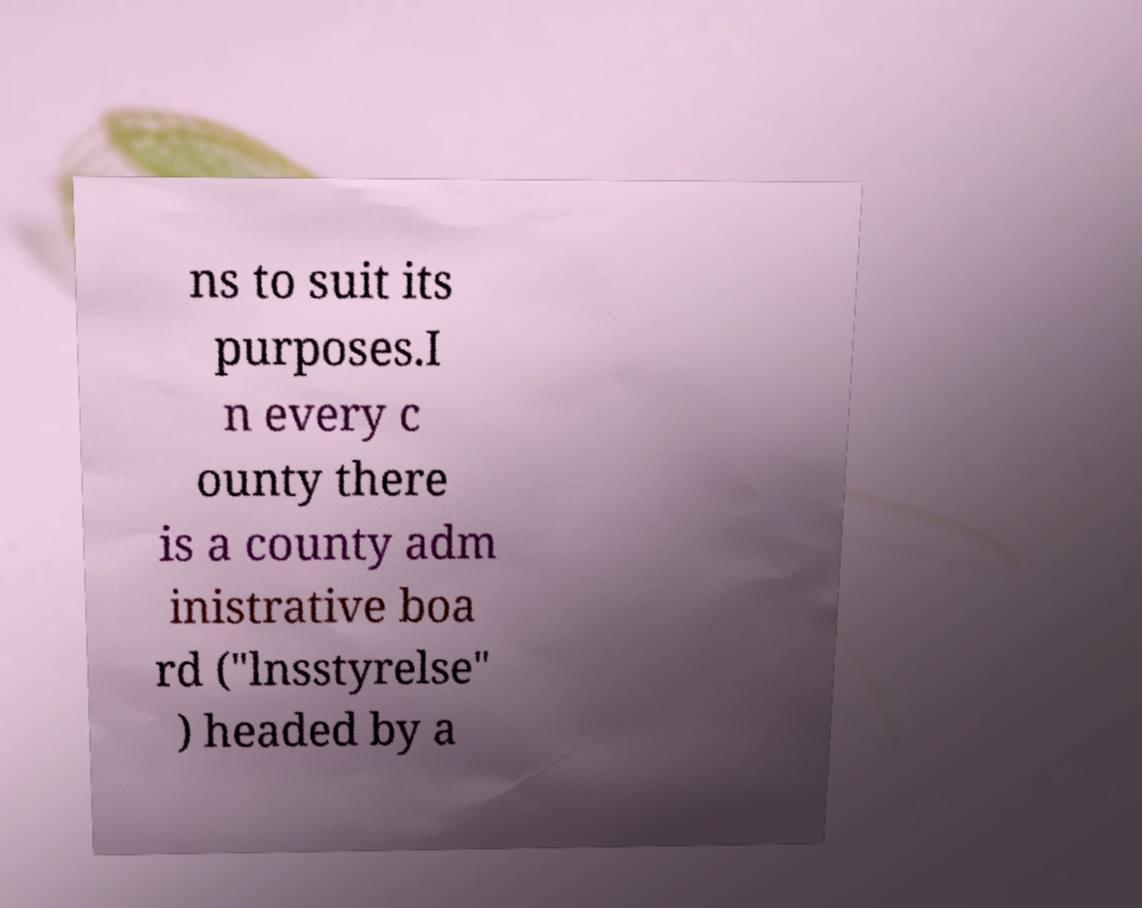For documentation purposes, I need the text within this image transcribed. Could you provide that? ns to suit its purposes.I n every c ounty there is a county adm inistrative boa rd ("lnsstyrelse" ) headed by a 